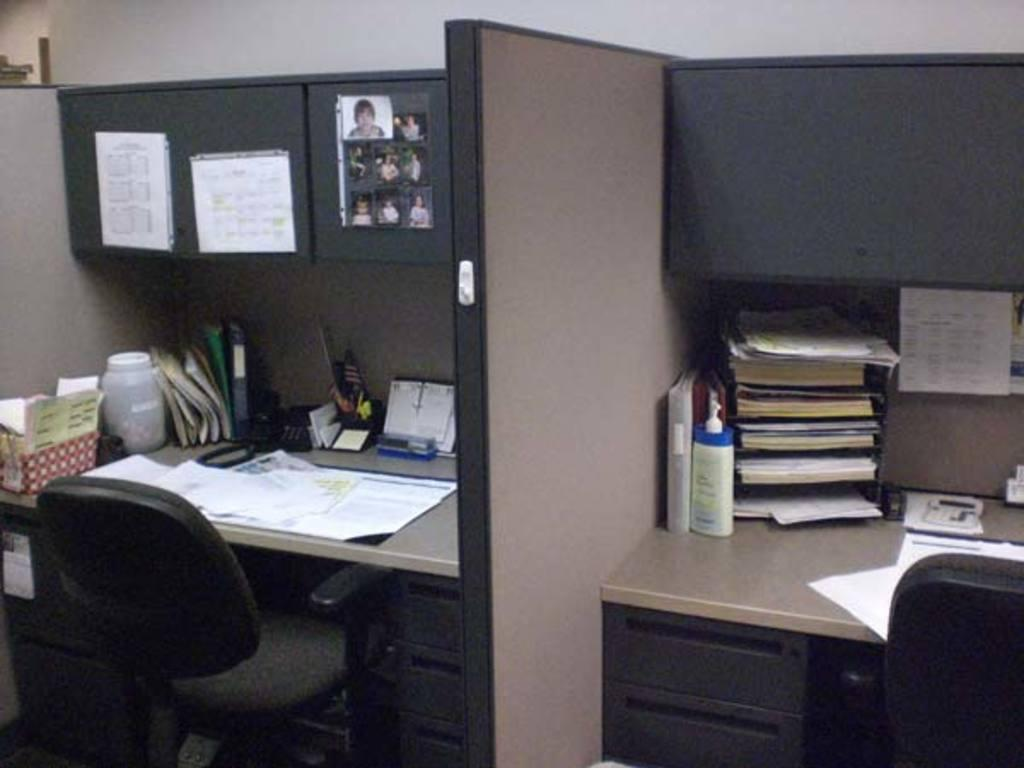How many tables are present in the image? There are two tables in the image. What is on each table? Each table has a desk. What items can be found on the desks? There are files, pens, a telephone, papers, pictures, and notes on the desks. How does the baby blow bubbles in the image? There is no baby or bubbles present in the image. 